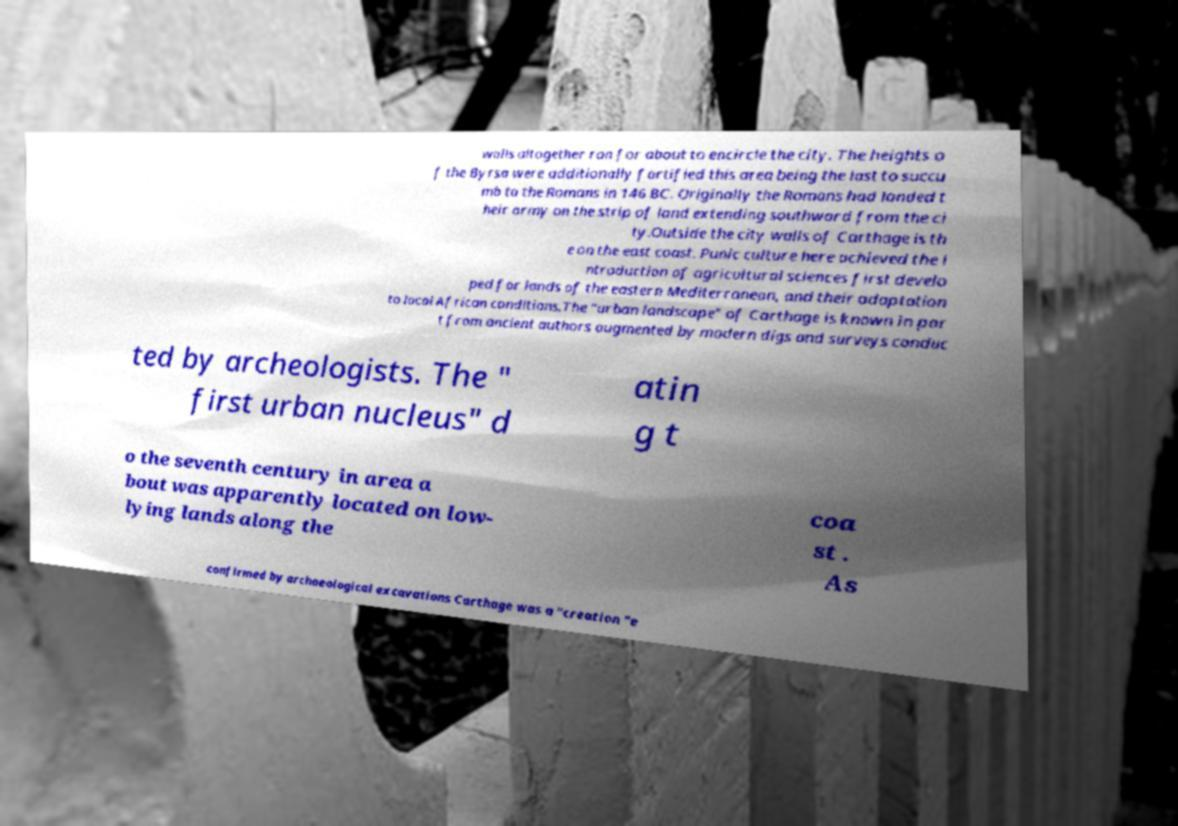For documentation purposes, I need the text within this image transcribed. Could you provide that? walls altogether ran for about to encircle the city. The heights o f the Byrsa were additionally fortified this area being the last to succu mb to the Romans in 146 BC. Originally the Romans had landed t heir army on the strip of land extending southward from the ci ty.Outside the city walls of Carthage is th e on the east coast. Punic culture here achieved the i ntroduction of agricultural sciences first develo ped for lands of the eastern Mediterranean, and their adaptation to local African conditions.The "urban landscape" of Carthage is known in par t from ancient authors augmented by modern digs and surveys conduc ted by archeologists. The " first urban nucleus" d atin g t o the seventh century in area a bout was apparently located on low- lying lands along the coa st . As confirmed by archaeological excavations Carthage was a "creation "e 